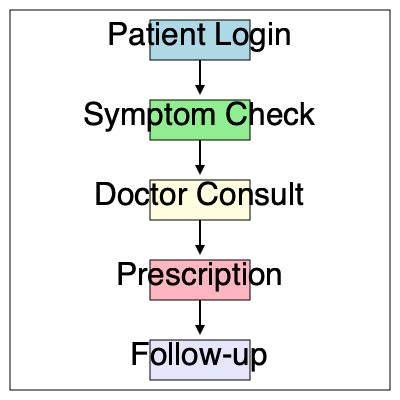In the virtual care appointment process flowchart, which step immediately follows the "Symptom Check" stage? To answer this question, we need to follow the steps in the flowchart:

1. The flowchart begins with "Patient Login" at the top.
2. An arrow leads from "Patient Login" to "Symptom Check".
3. The next arrow leads from "Symptom Check" to the next step.
4. Following this arrow, we can see that the step immediately after "Symptom Check" is "Doctor Consult".
5. After "Doctor Consult", the flowchart continues with "Prescription" and then "Follow-up".

Therefore, in this virtual care appointment process, the step that immediately follows the "Symptom Check" stage is "Doctor Consult".
Answer: Doctor Consult 